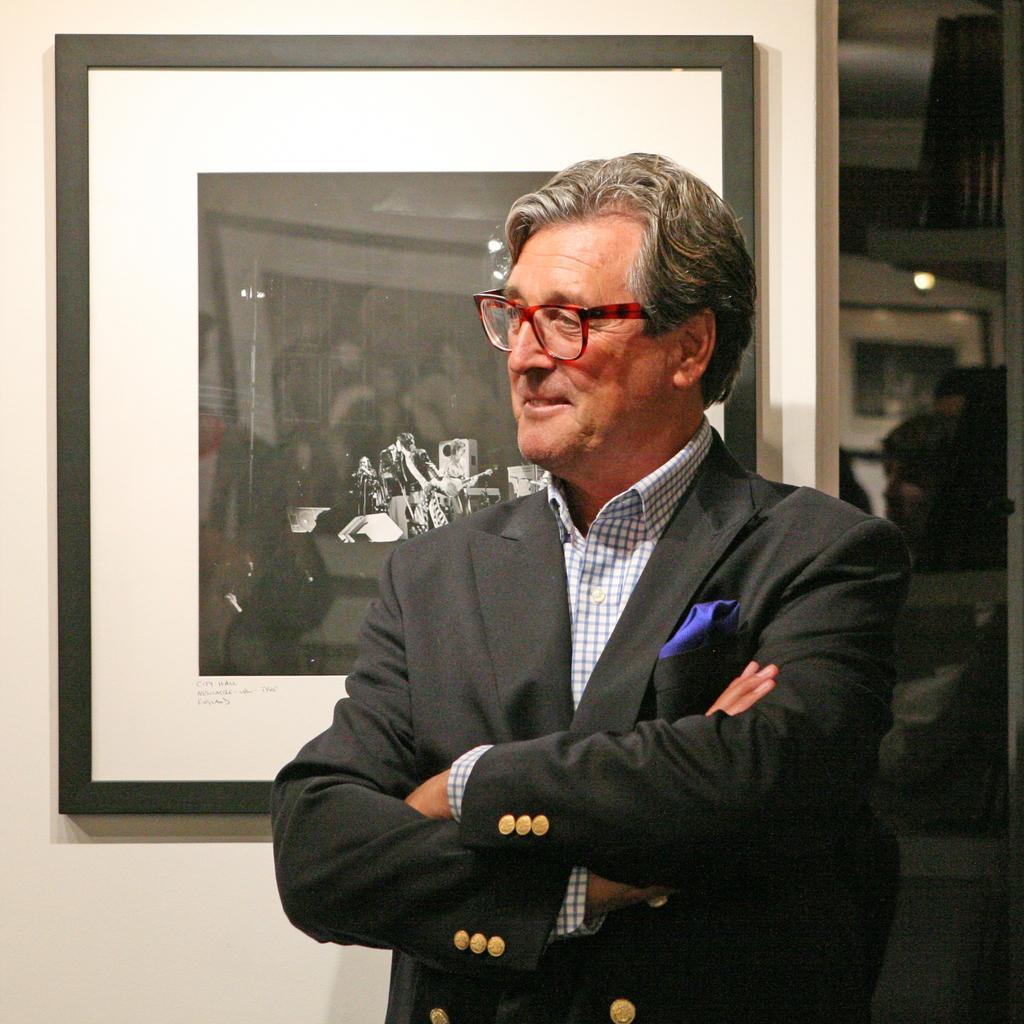Describe this image in one or two sentences. In the foreground I can see a person is standing on the floor in suit and a photo frame. In the background I can see a group of people, lights and rooftop. This image is taken may be in a hall. 